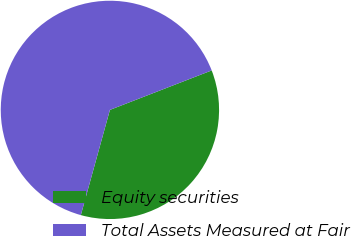<chart> <loc_0><loc_0><loc_500><loc_500><pie_chart><fcel>Equity securities<fcel>Total Assets Measured at Fair<nl><fcel>35.18%<fcel>64.82%<nl></chart> 